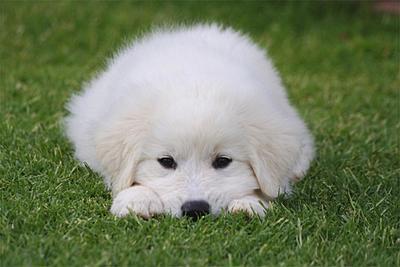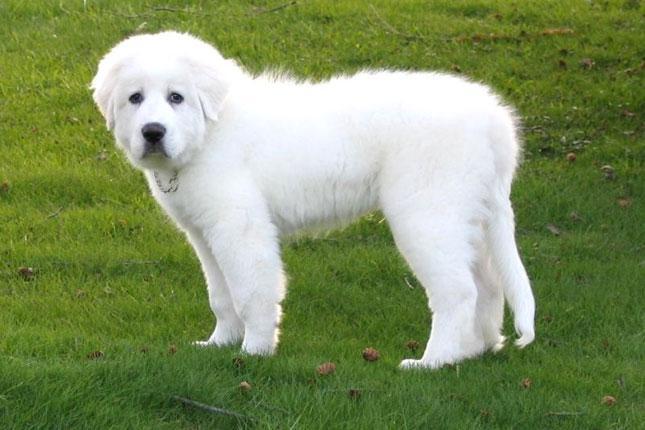The first image is the image on the left, the second image is the image on the right. Given the left and right images, does the statement "The white dog is lying in the grass in the image on the left." hold true? Answer yes or no. Yes. The first image is the image on the left, the second image is the image on the right. Evaluate the accuracy of this statement regarding the images: "An image shows a white dog with a herd of livestock.". Is it true? Answer yes or no. No. 